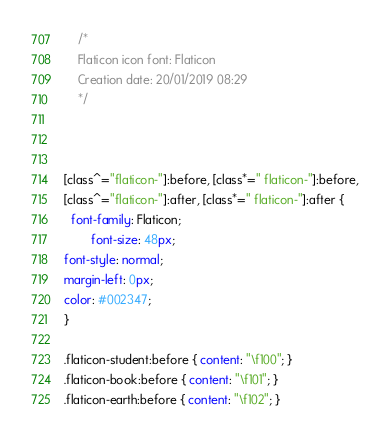Convert code to text. <code><loc_0><loc_0><loc_500><loc_500><_CSS_>	/*
  	Flaticon icon font: Flaticon
  	Creation date: 20/01/2019 08:29
  	*/



[class^="flaticon-"]:before, [class*=" flaticon-"]:before,
[class^="flaticon-"]:after, [class*=" flaticon-"]:after {   
  font-family: Flaticon;
        font-size: 48px;
font-style: normal;
margin-left: 0px;
color: #002347;
}

.flaticon-student:before { content: "\f100"; }
.flaticon-book:before { content: "\f101"; }
.flaticon-earth:before { content: "\f102"; }</code> 